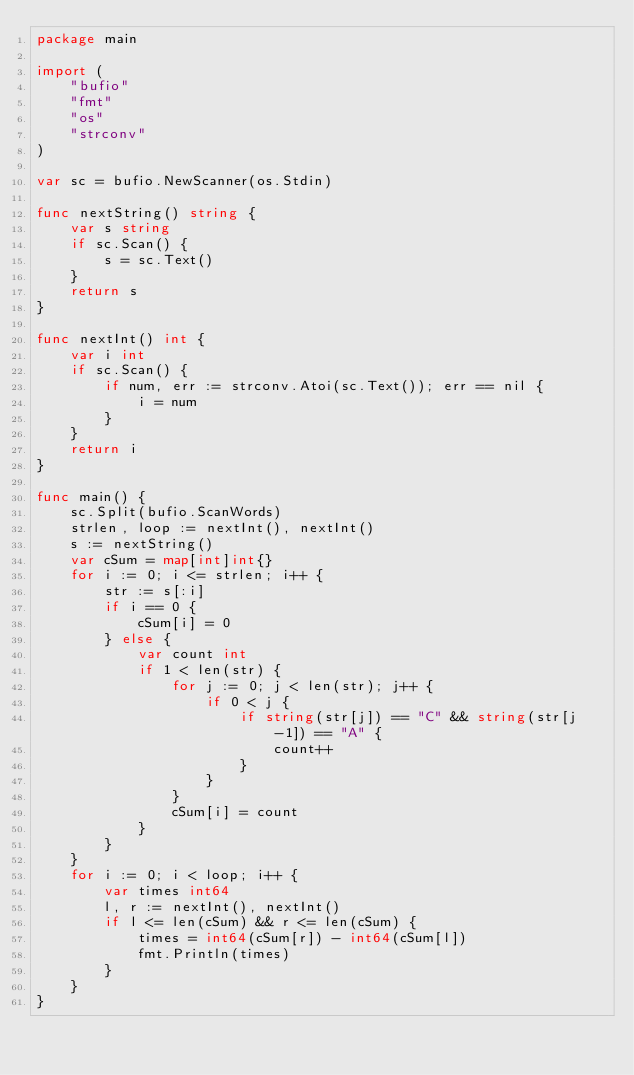Convert code to text. <code><loc_0><loc_0><loc_500><loc_500><_Go_>package main

import (
	"bufio"
	"fmt"
	"os"
	"strconv"
)

var sc = bufio.NewScanner(os.Stdin)

func nextString() string {
	var s string
	if sc.Scan() {
		s = sc.Text()
	}
	return s
}

func nextInt() int {
	var i int
	if sc.Scan() {
		if num, err := strconv.Atoi(sc.Text()); err == nil {
			i = num
		}
	}
	return i
}

func main() {
	sc.Split(bufio.ScanWords)
	strlen, loop := nextInt(), nextInt()
	s := nextString()
	var cSum = map[int]int{}
	for i := 0; i <= strlen; i++ {
		str := s[:i]
		if i == 0 {
			cSum[i] = 0
		} else {
			var count int
			if 1 < len(str) {
				for j := 0; j < len(str); j++ {
					if 0 < j {
						if string(str[j]) == "C" && string(str[j-1]) == "A" {
							count++
						}
					}
				}
				cSum[i] = count
			}
		}
	}
	for i := 0; i < loop; i++ {
		var times int64
		l, r := nextInt(), nextInt()
		if l <= len(cSum) && r <= len(cSum) {
			times = int64(cSum[r]) - int64(cSum[l])
			fmt.Println(times)
		}
	}
}
</code> 